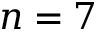Convert formula to latex. <formula><loc_0><loc_0><loc_500><loc_500>n = 7</formula> 